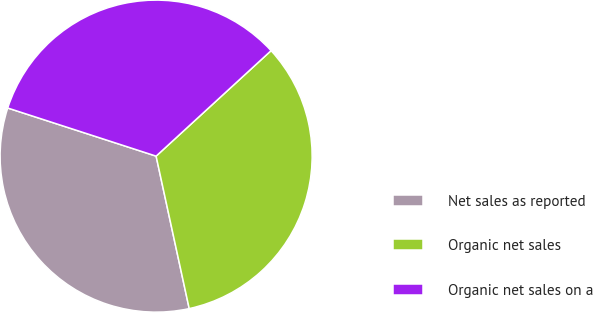Convert chart. <chart><loc_0><loc_0><loc_500><loc_500><pie_chart><fcel>Net sales as reported<fcel>Organic net sales<fcel>Organic net sales on a<nl><fcel>33.39%<fcel>33.41%<fcel>33.19%<nl></chart> 